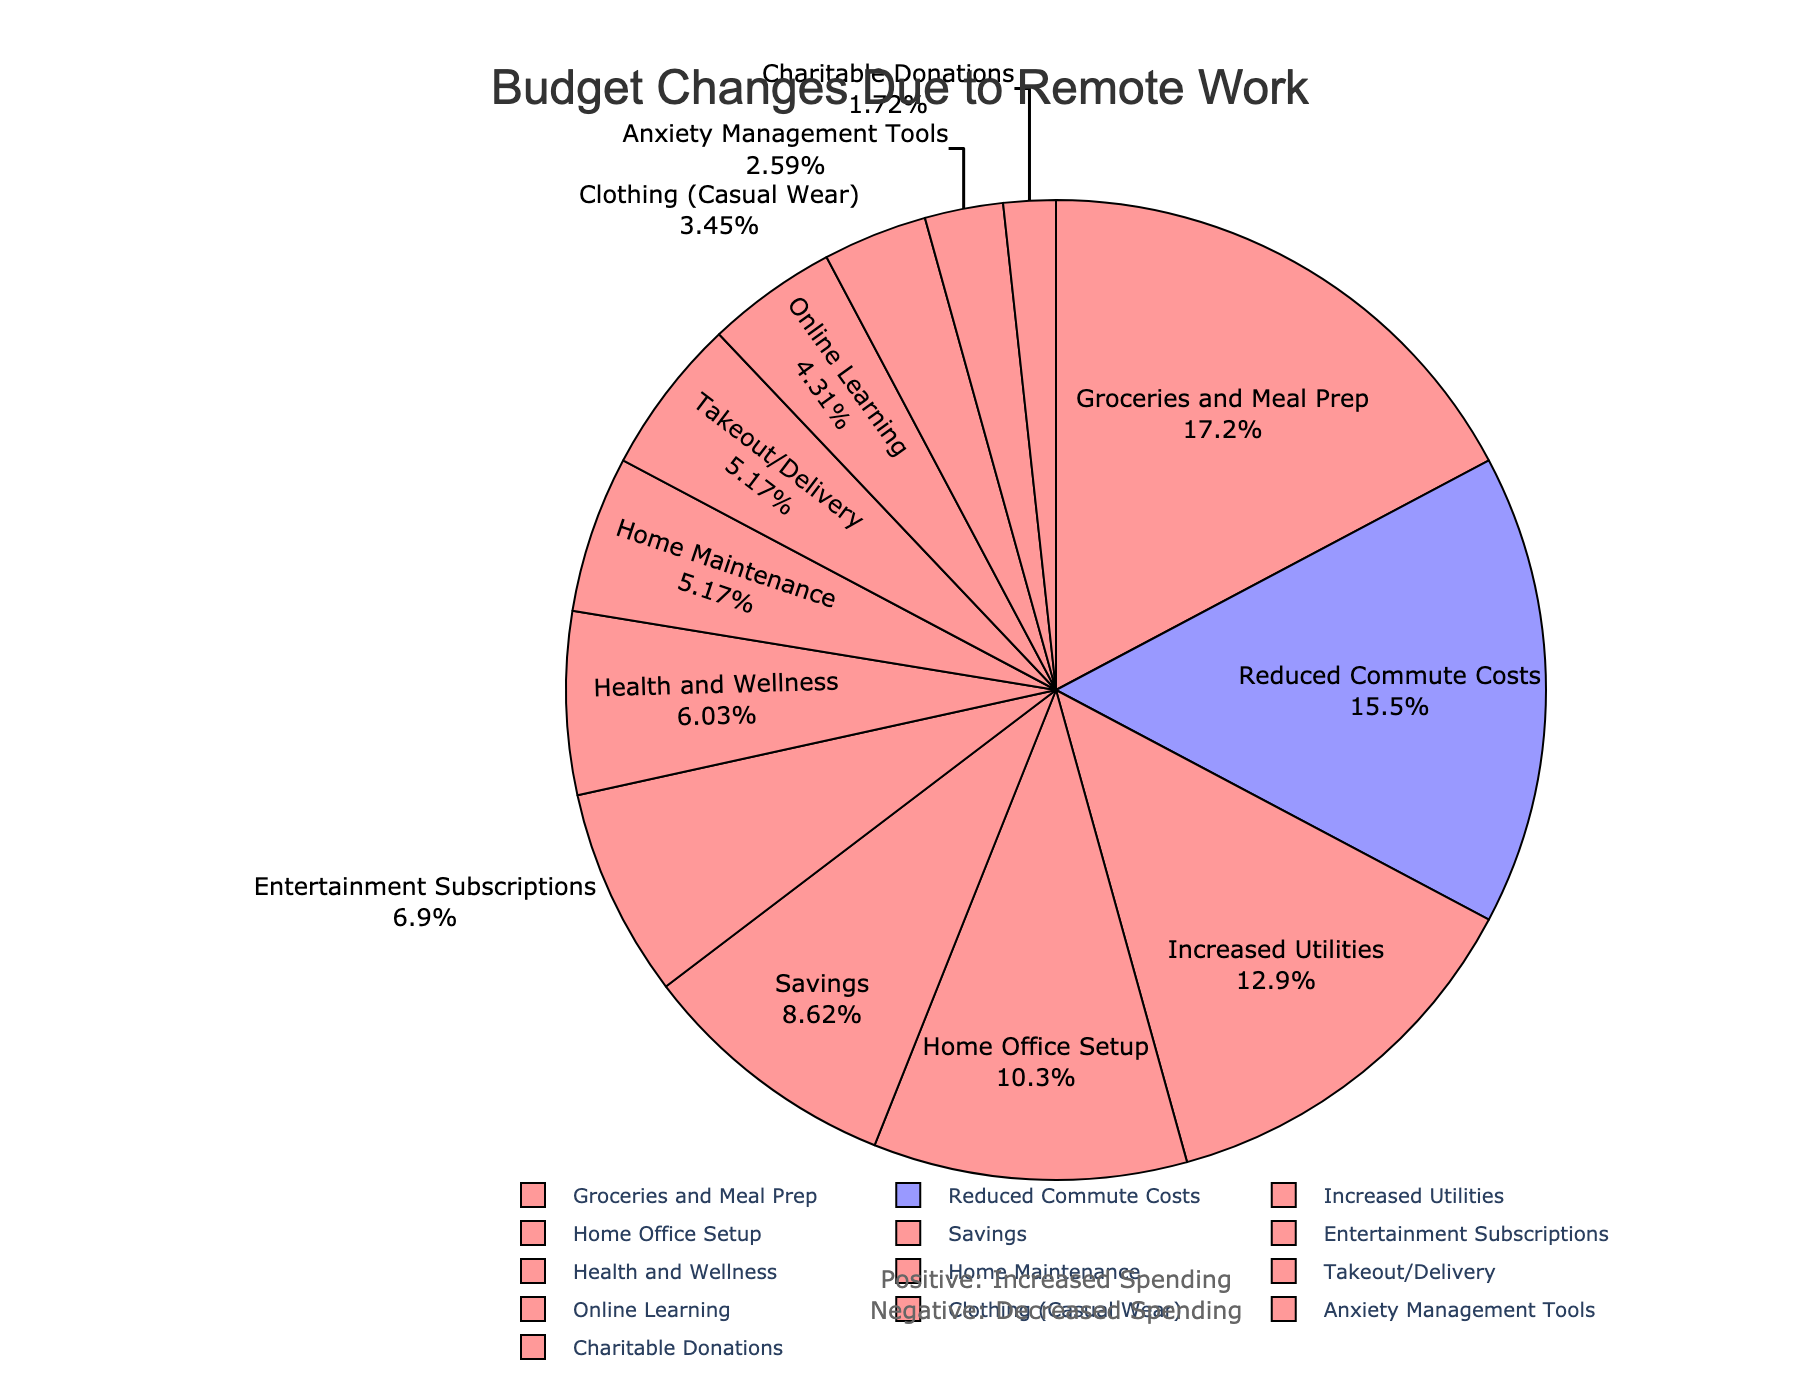Which category saw the largest decrease in spending? Look for the category with the largest negative percentage. The category "Reduced Commute Costs" has decreased by 18%, which is the largest decrease.
Answer: Reduced Commute Costs Which category accounts for the largest increase in spending? Identify the category with the largest positive percentage. The category "Groceries and Meal Prep" has increased by 20%, the highest among all increases.
Answer: Groceries and Meal Prep What is the sum of the percentages for categories with increased spending? Sum the percentages of categories with positive values: 15 (Increased Utilities) + 20 (Groceries and Meal Prep) + 12 (Home Office Setup) + 10 (Savings) + 8 (Entertainment Subscriptions) + 7 (Health and Wellness) + 5 (Online Learning) + 6 (Home Maintenance) + 4 (Clothing - Casual Wear) + 6 (Takeout/Delivery) + 3 (Anxiety Management Tools) + 2 (Charitable Donations) = 98.
Answer: 98 How does the spending on Home Office Setup compare to that on Savings? Compare the percentages of both categories. "Home Office Setup" has 12% while "Savings" has 10%. Therefore, spending on Home Office Setup is greater.
Answer: Home Office Setup is greater What color represents the increased spending on Groceries and Meal Prep? Groceries and Meal Prep has a positive percentage, which is represented by the color red (#FF9999).
Answer: Red What is the combined percentage of spending on Entertainment Subscriptions and Health and Wellness? Sum the percentages of "Entertainment Subscriptions" and "Health and Wellness". 8 (Entertainment Subscriptions) + 7 (Health and Wellness) = 15.
Answer: 15 Which categories have a percentage value of less than 5%? Identify categories with percentages less than 5. There are "Clothing (Casual Wear)" with 4% and "Charitable Donations" with 2%.
Answer: Clothing (Casual Wear) and Charitable Donations Which category is represented by a percentage of 6% and what color is it? Find the category with 6%. "Home Maintenance" and "Takeout/Delivery" both have 6%. Since 6% is positive, the color is red.
Answer: Home Maintenance and Takeout/Delivery, Red 